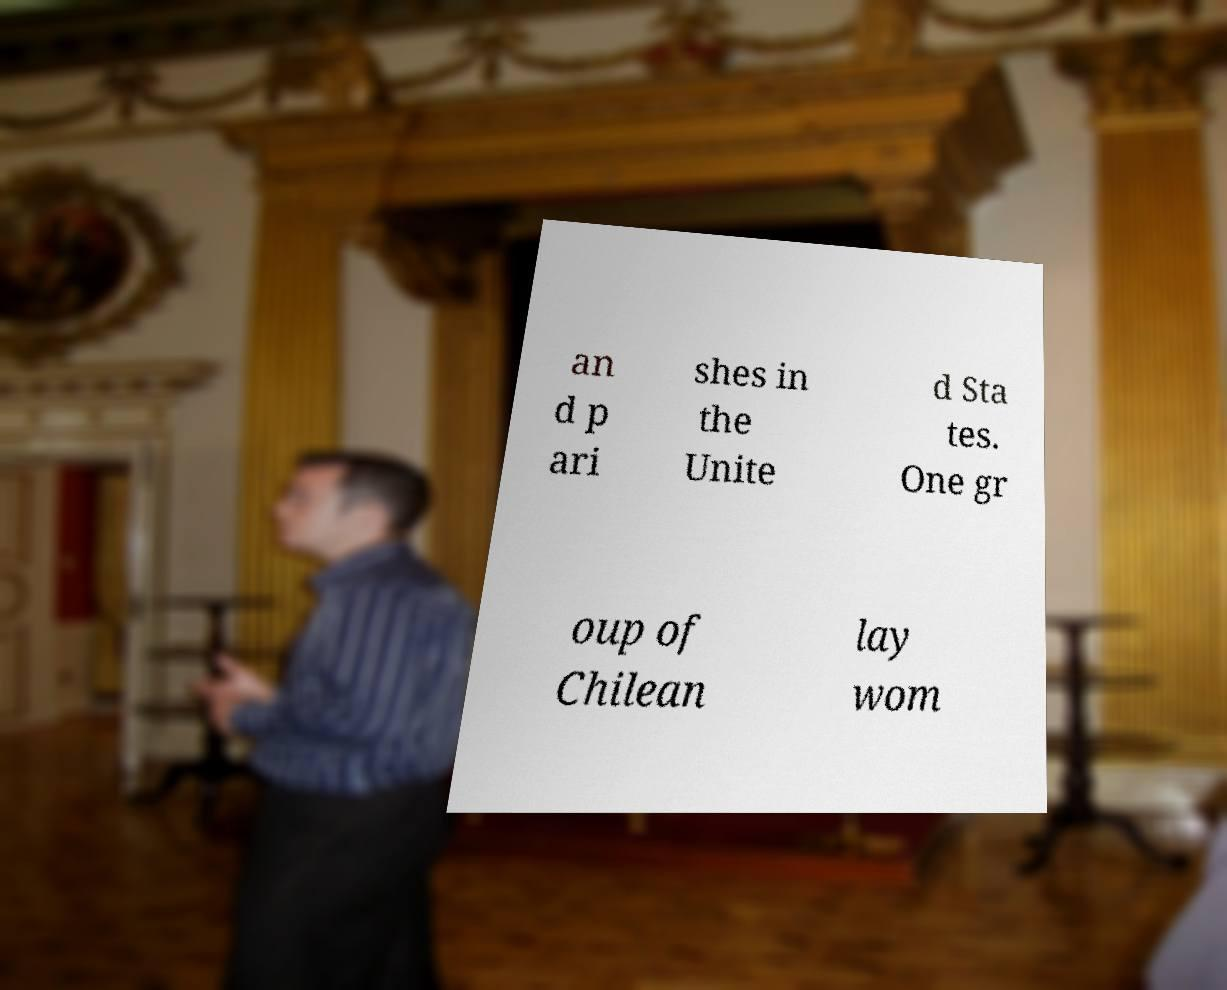What messages or text are displayed in this image? I need them in a readable, typed format. an d p ari shes in the Unite d Sta tes. One gr oup of Chilean lay wom 